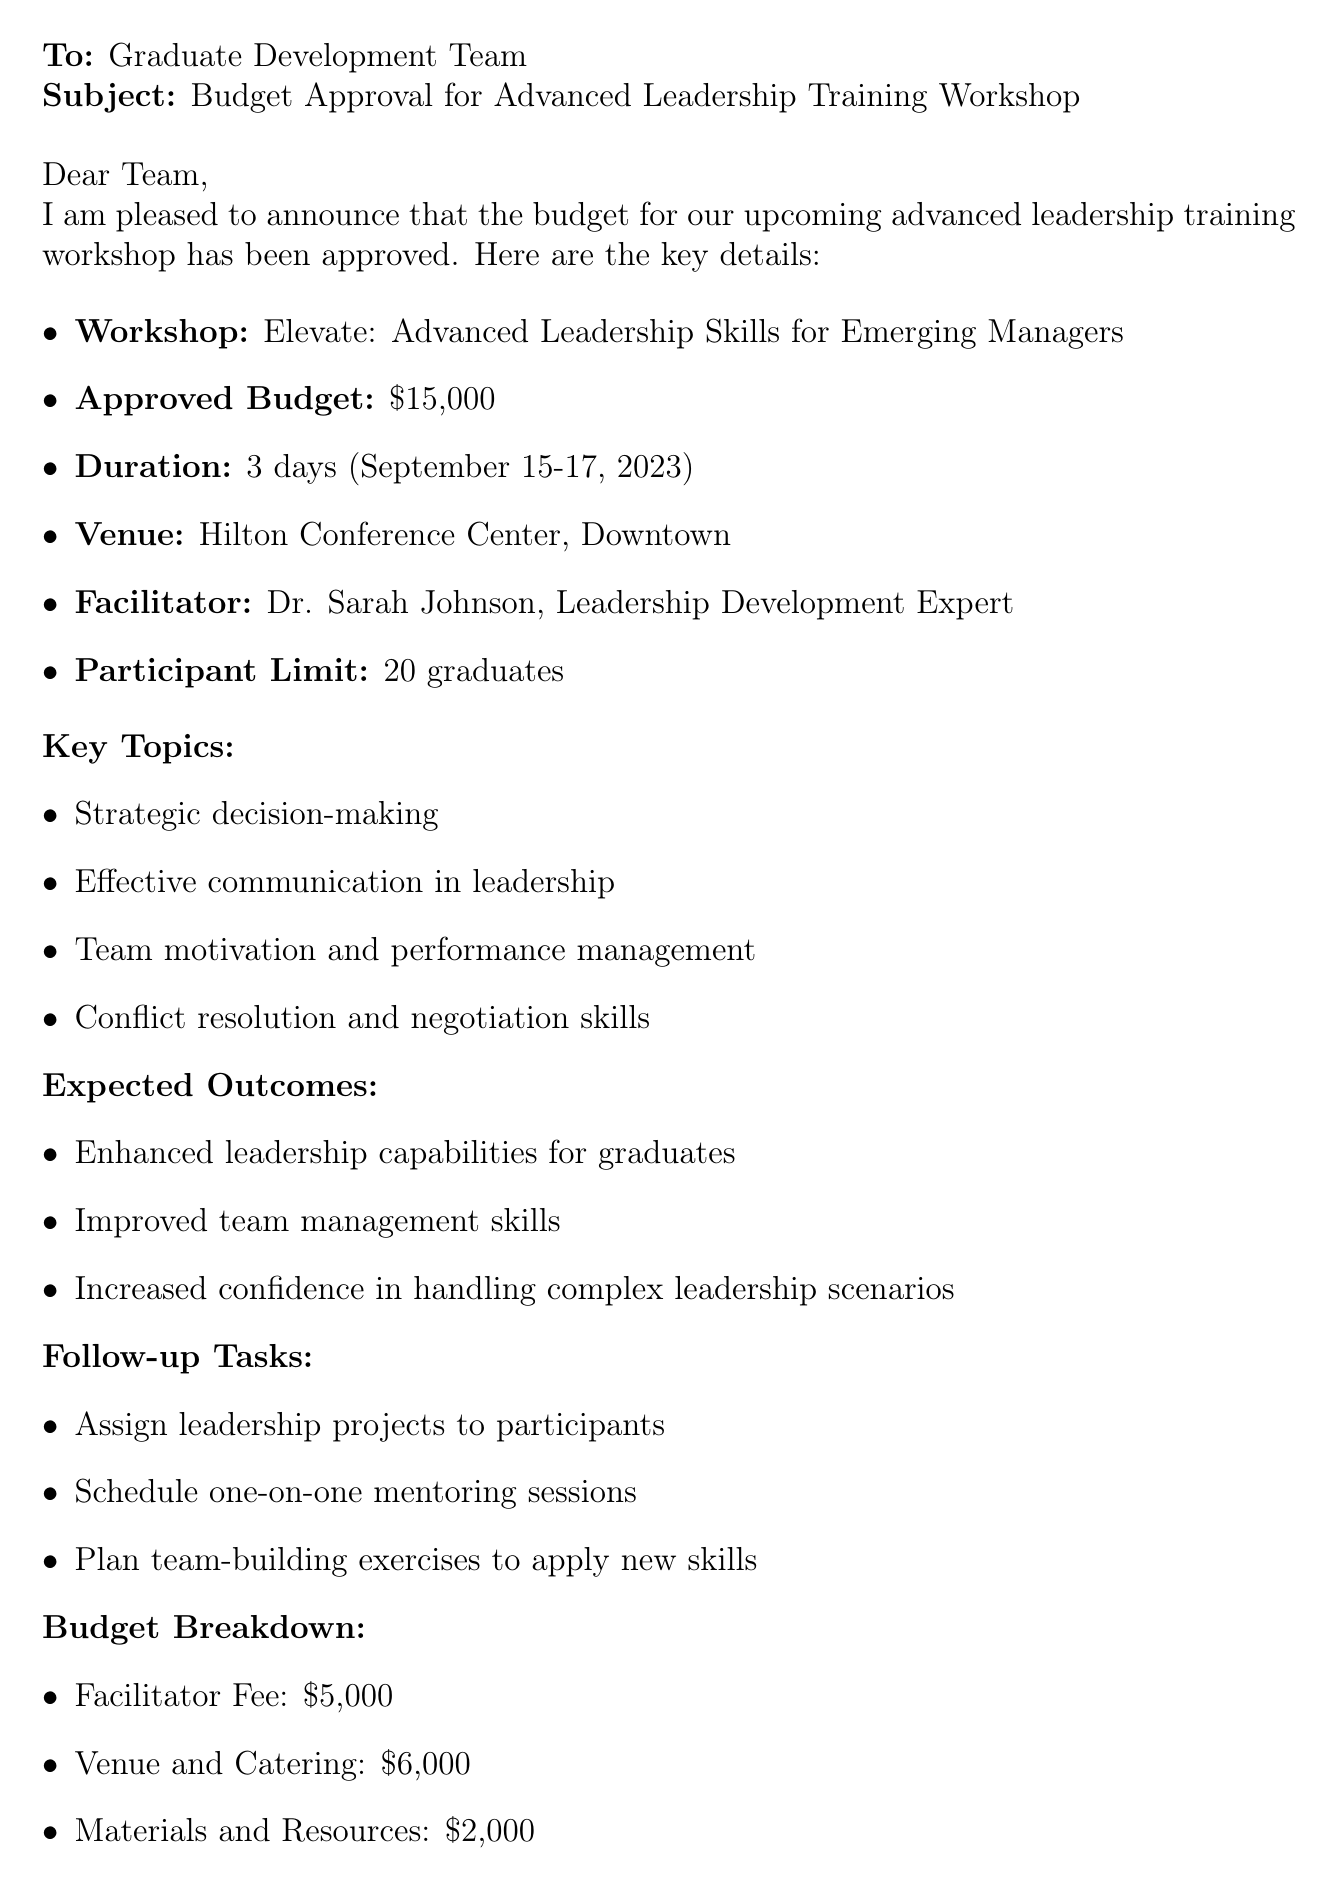What is the workshop name? The workshop name is specified in the document as "Elevate: Advanced Leadership Skills for Emerging Managers."
Answer: Elevate: Advanced Leadership Skills for Emerging Managers What is the approved budget? The approved budget is listed in the document as $15,000.
Answer: $15,000 Who is the facilitator? The facilitator's name is provided in the document as Dr. Sarah Johnson.
Answer: Dr. Sarah Johnson What is the duration of the workshop? The duration is indicated in the document as 3 days.
Answer: 3 days What are the key topics? The key topics include several areas such as "Strategic decision-making," and "Team motivation and performance management," as outlined in the document.
Answer: Strategic decision-making, Effective communication in leadership, Team motivation and performance management, Conflict resolution and negotiation skills What are the expected outcomes of the workshop? The expected outcomes include enhanced leadership capabilities and improved team management skills, as detailed in the document.
Answer: Enhanced leadership capabilities for graduates, Improved team management skills, Increased confidence in handling complex leadership scenarios What is the participant limit for the workshop? The participant limit is specified in the document as 20 graduates.
Answer: 20 graduates What is the venue for the workshop? The venue is stated as Hilton Conference Center, Downtown.
Answer: Hilton Conference Center, Downtown Who approved the budget? The approval authority mentioned in the document is Jennifer Thompson.
Answer: Jennifer Thompson 